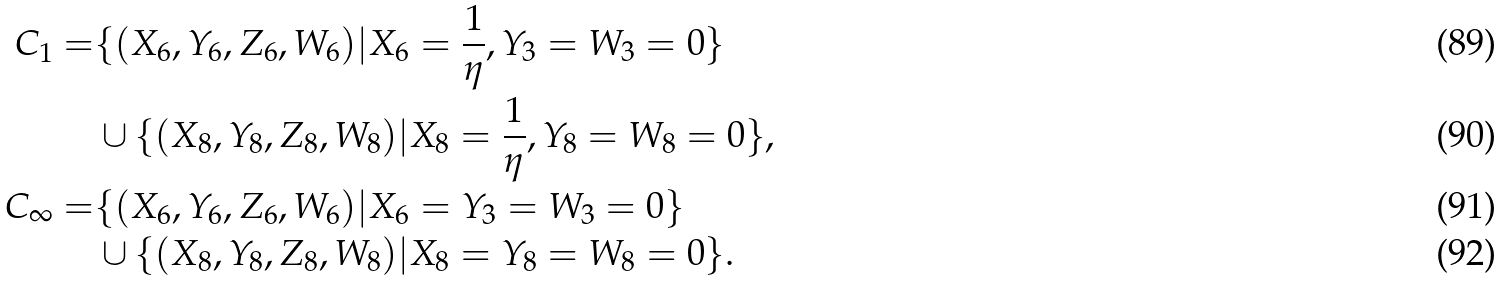<formula> <loc_0><loc_0><loc_500><loc_500>C _ { 1 } = & \{ ( X _ { 6 } , Y _ { 6 } , Z _ { 6 } , W _ { 6 } ) | X _ { 6 } = \frac { 1 } { \eta } , Y _ { 3 } = W _ { 3 } = 0 \} \\ & \cup \{ ( X _ { 8 } , Y _ { 8 } , Z _ { 8 } , W _ { 8 } ) | X _ { 8 } = \frac { 1 } { \eta } , Y _ { 8 } = W _ { 8 } = 0 \} , \\ C _ { \infty } = & \{ ( X _ { 6 } , Y _ { 6 } , Z _ { 6 } , W _ { 6 } ) | X _ { 6 } = Y _ { 3 } = W _ { 3 } = 0 \} \\ & \cup \{ ( X _ { 8 } , Y _ { 8 } , Z _ { 8 } , W _ { 8 } ) | X _ { 8 } = Y _ { 8 } = W _ { 8 } = 0 \} .</formula> 